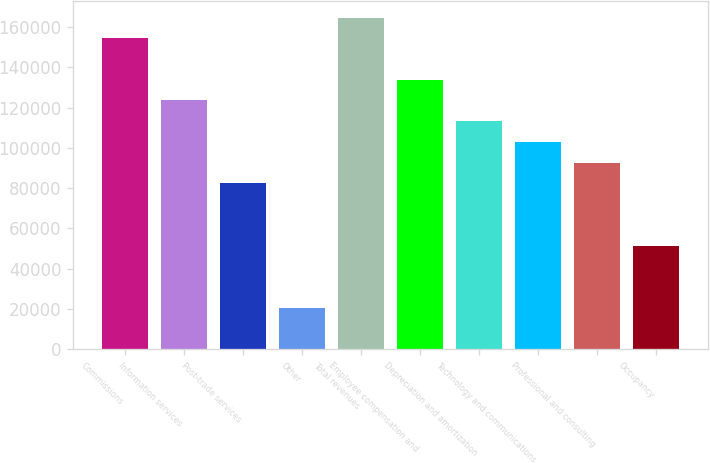Convert chart to OTSL. <chart><loc_0><loc_0><loc_500><loc_500><bar_chart><fcel>Commissions<fcel>Information services<fcel>Post-trade services<fcel>Other<fcel>Total revenues<fcel>Employee compensation and<fcel>Depreciation and amortization<fcel>Technology and communications<fcel>Professional and consulting<fcel>Occupancy<nl><fcel>154445<fcel>123557<fcel>82371.4<fcel>20593.7<fcel>164742<fcel>133853<fcel>113260<fcel>102964<fcel>92667.7<fcel>51482.6<nl></chart> 